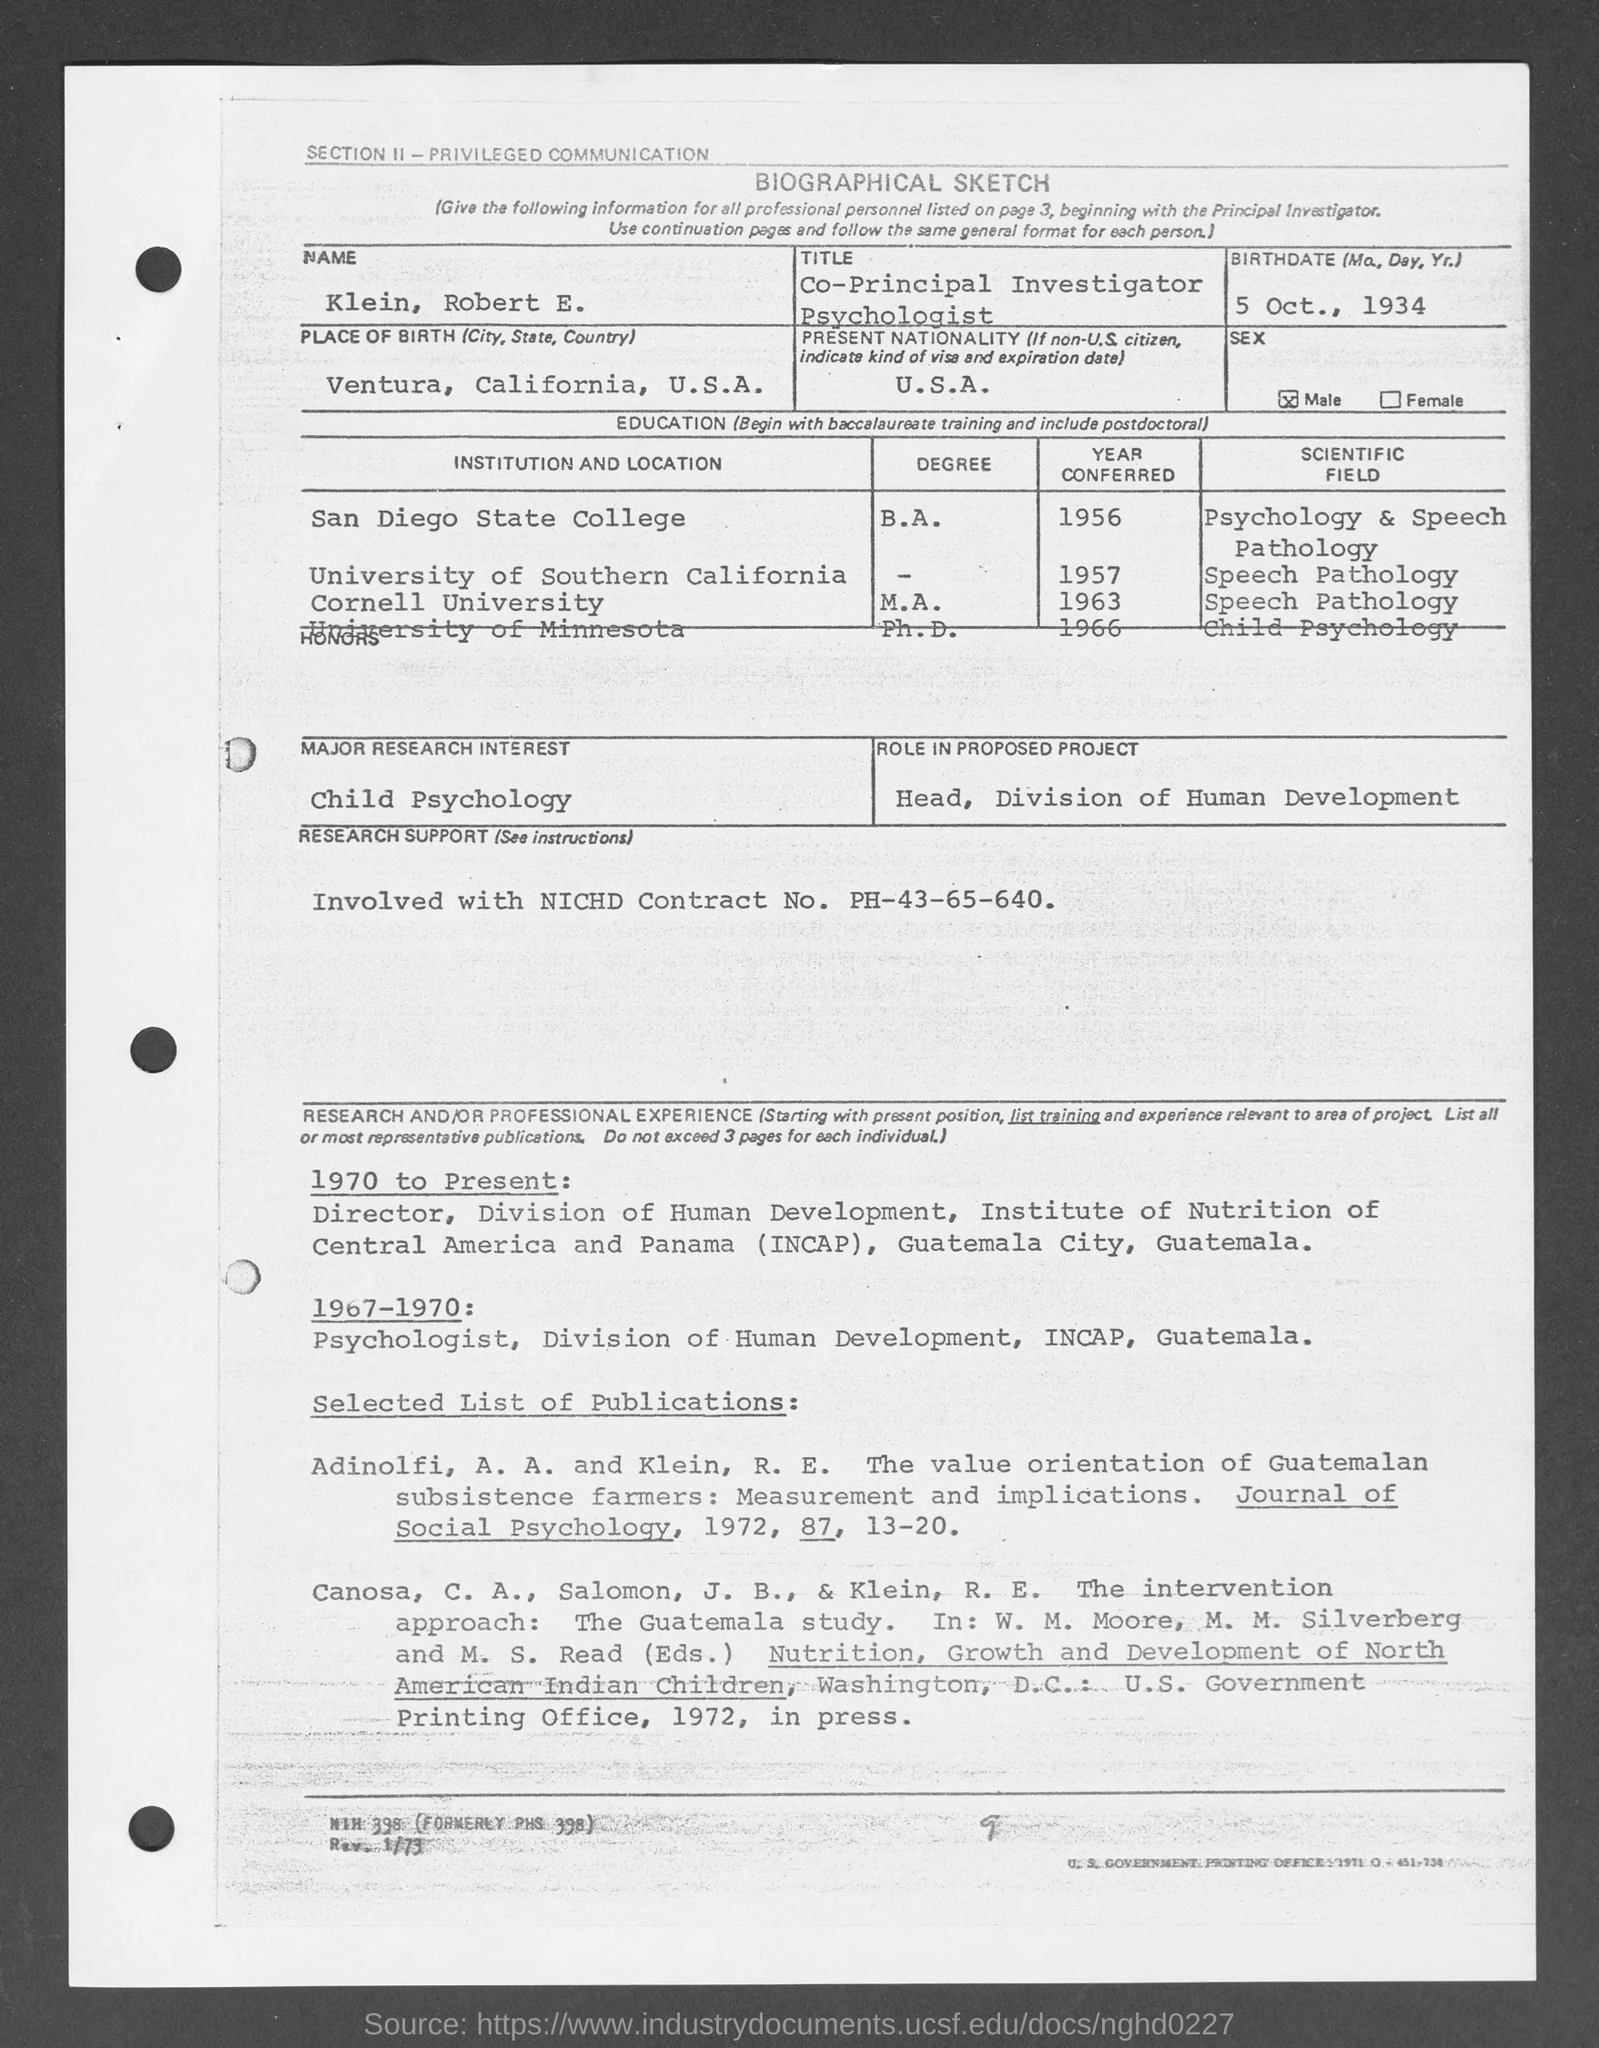What is the title of the document?
Provide a succinct answer. Biographical Sketch. What is the Name??
Keep it short and to the point. Klein, Robert E. What is the Title?
Your answer should be compact. Co-Principal Investigator Psychologist. What is the Birthdate?
Provide a succinct answer. 5 Oct., 1934. What is the Place of birth?
Give a very brief answer. Ventura, California, U.S.A. What is the Present Nationality?
Your response must be concise. U.S.A. What is the Major Research Interest?
Offer a terse response. Child Psychology. What is the Role in proposed project?
Your response must be concise. Head, Division of Human Development. When was he in San Diego State College?
Offer a terse response. 1956. When was he in Cornell University?
Ensure brevity in your answer.  1963. 